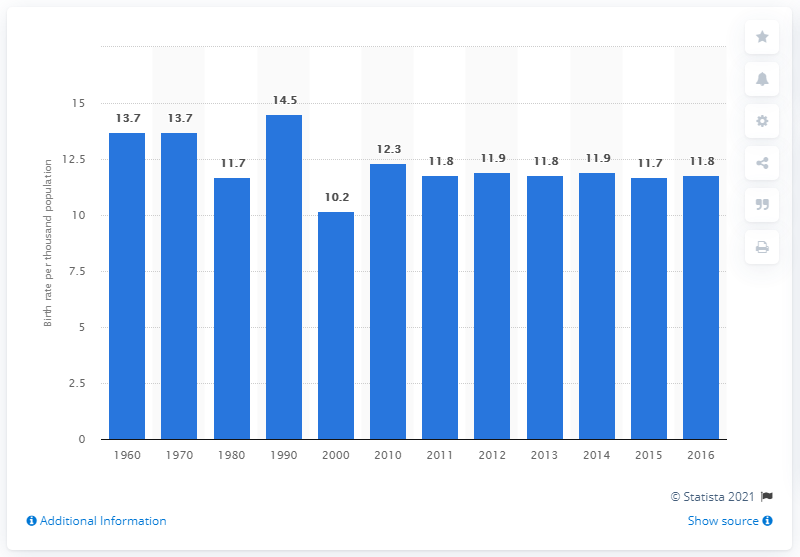Give some essential details in this illustration. In 2000, the crude birth rate in Sweden was 10.2 per thousand population. In 2016, the crude birth rate in Sweden was 11.8 per thousand population. 